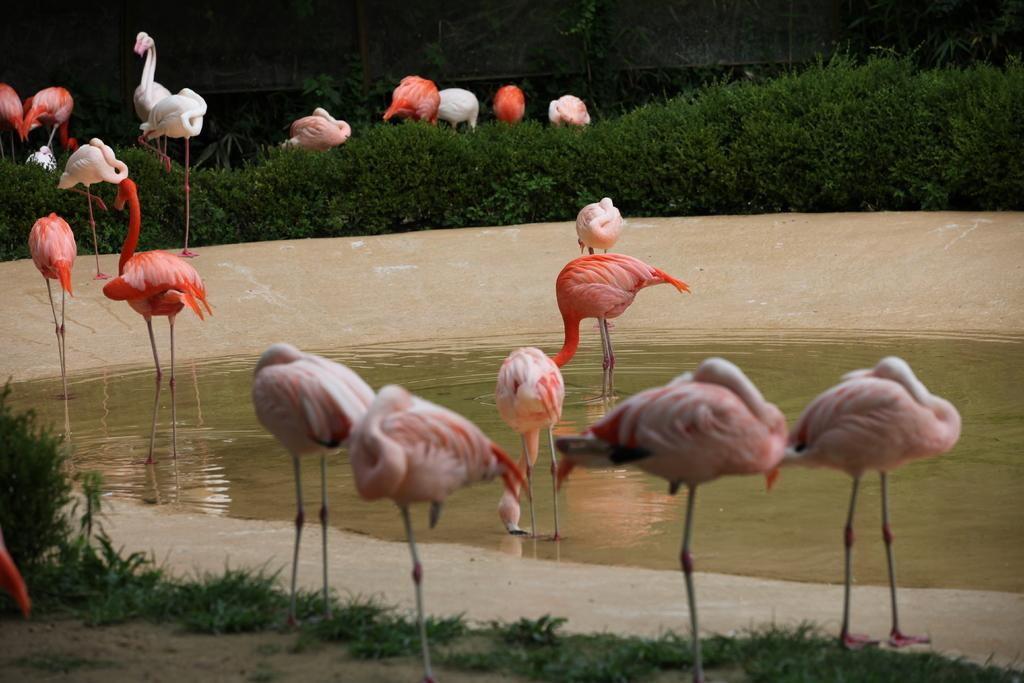What is the primary element visible in the image? There is water in the image. What type of birds can be seen in the image? There are cranes in the image. What type of vegetation is present in the image? There is grass and plants in the image. What type of veil can be seen covering the plants in the image? There is no veil present in the image; the plants are not covered. 